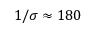Convert formula to latex. <formula><loc_0><loc_0><loc_500><loc_500>1 / \sigma \approx 1 8 0</formula> 